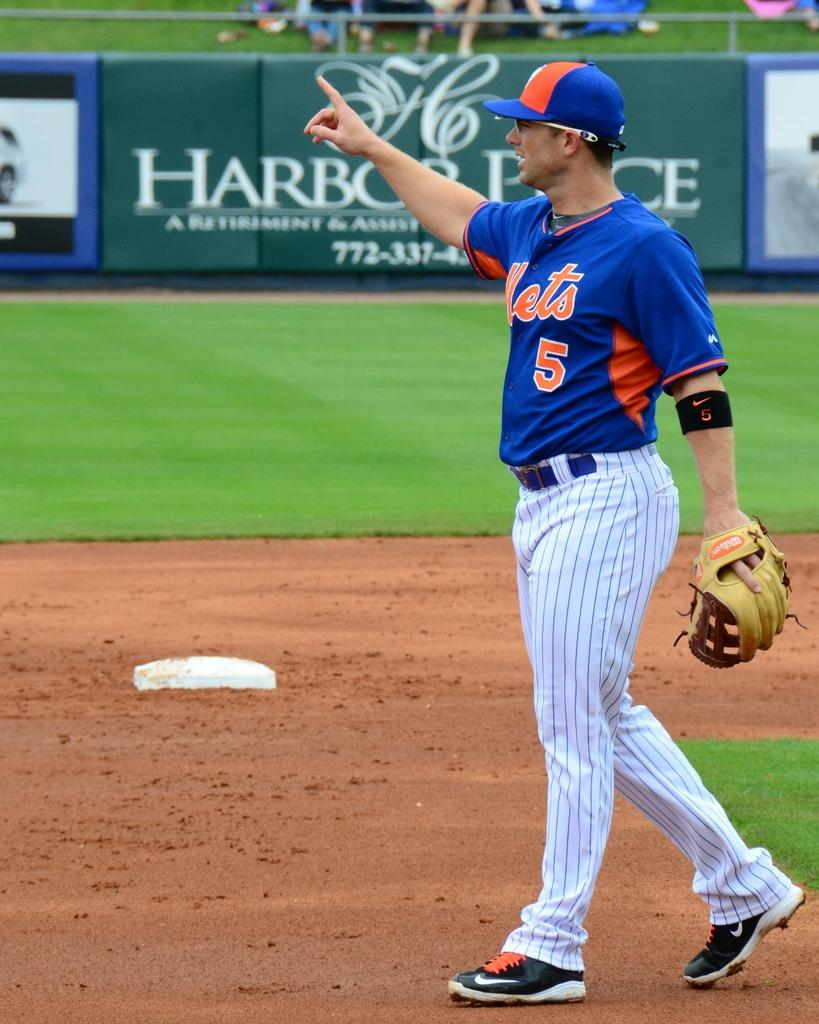<image>
Describe the image concisely. Player number 5 from the Mets is out in the field holding a glove in one hand and raising the other hand and pointing a finger up in the air. 